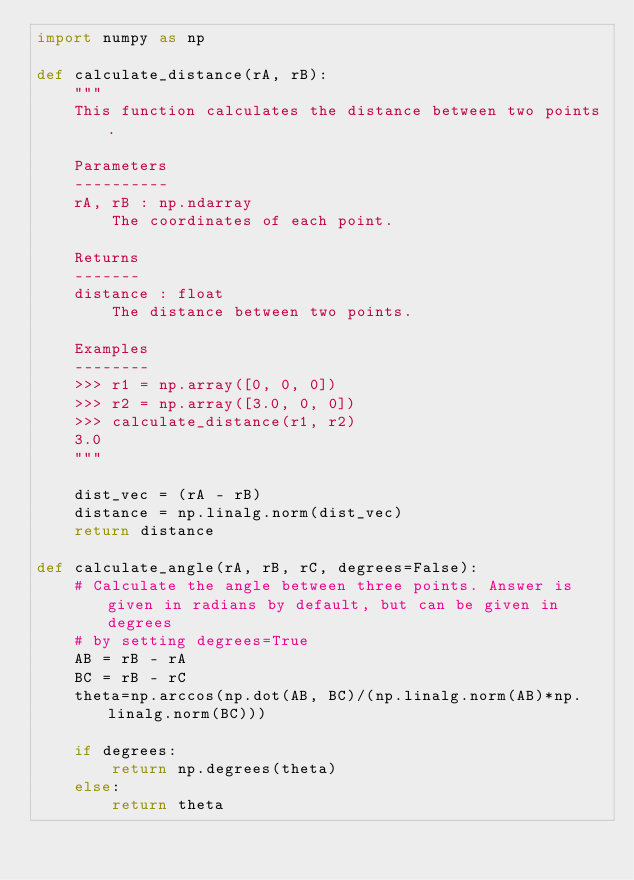<code> <loc_0><loc_0><loc_500><loc_500><_Python_>import numpy as np

def calculate_distance(rA, rB):
    """
    This function calculates the distance between two points.

    Parameters
    ----------
    rA, rB : np.ndarray
        The coordinates of each point.

    Returns
    -------
    distance : float
        The distance between two points.

    Examples
    --------
    >>> r1 = np.array([0, 0, 0])
    >>> r2 = np.array([3.0, 0, 0])
    >>> calculate_distance(r1, r2)
    3.0
    """

    dist_vec = (rA - rB)
    distance = np.linalg.norm(dist_vec)
    return distance

def calculate_angle(rA, rB, rC, degrees=False):
    # Calculate the angle between three points. Answer is given in radians by default, but can be given in degrees
    # by setting degrees=True
    AB = rB - rA
    BC = rB - rC
    theta=np.arccos(np.dot(AB, BC)/(np.linalg.norm(AB)*np.linalg.norm(BC)))

    if degrees:
        return np.degrees(theta)
    else:
        return theta
</code> 